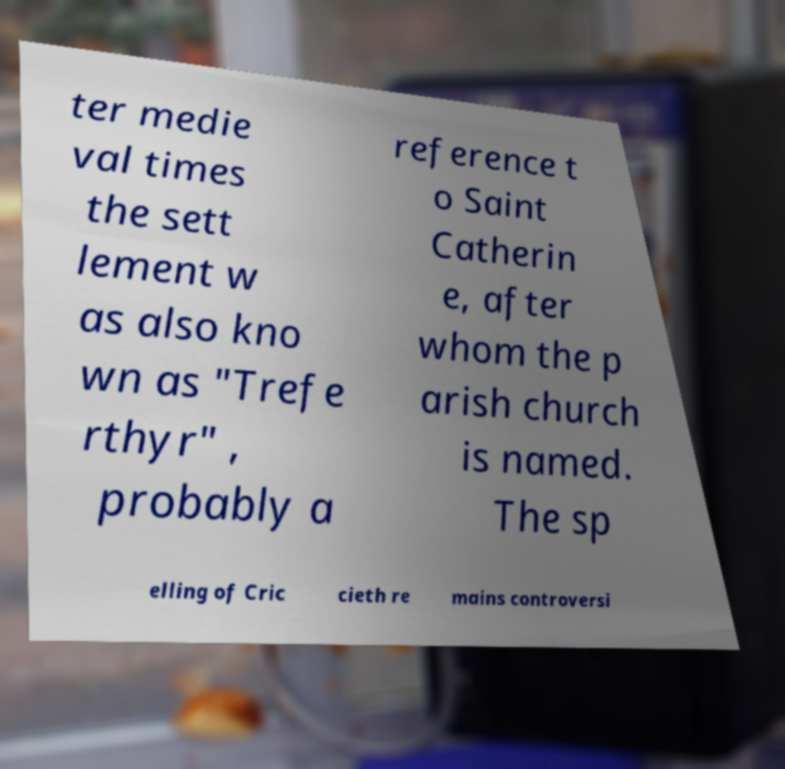There's text embedded in this image that I need extracted. Can you transcribe it verbatim? ter medie val times the sett lement w as also kno wn as "Trefe rthyr" , probably a reference t o Saint Catherin e, after whom the p arish church is named. The sp elling of Cric cieth re mains controversi 